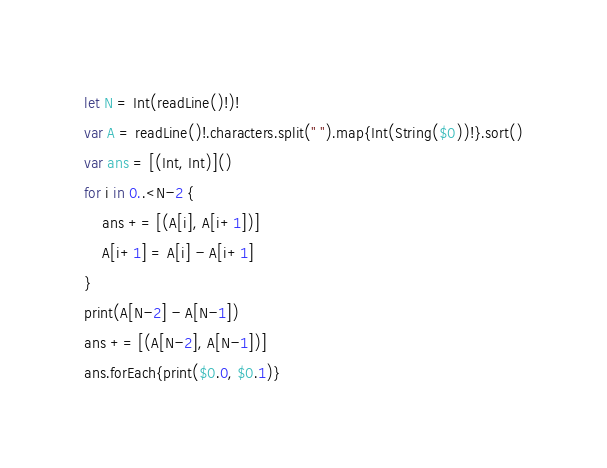Convert code to text. <code><loc_0><loc_0><loc_500><loc_500><_Swift_>let N = Int(readLine()!)!
var A = readLine()!.characters.split(" ").map{Int(String($0))!}.sort()
var ans = [(Int, Int)]()
for i in 0..<N-2 {
    ans += [(A[i], A[i+1])]
    A[i+1] = A[i] - A[i+1]
}
print(A[N-2] - A[N-1])
ans += [(A[N-2], A[N-1])]
ans.forEach{print($0.0, $0.1)}</code> 